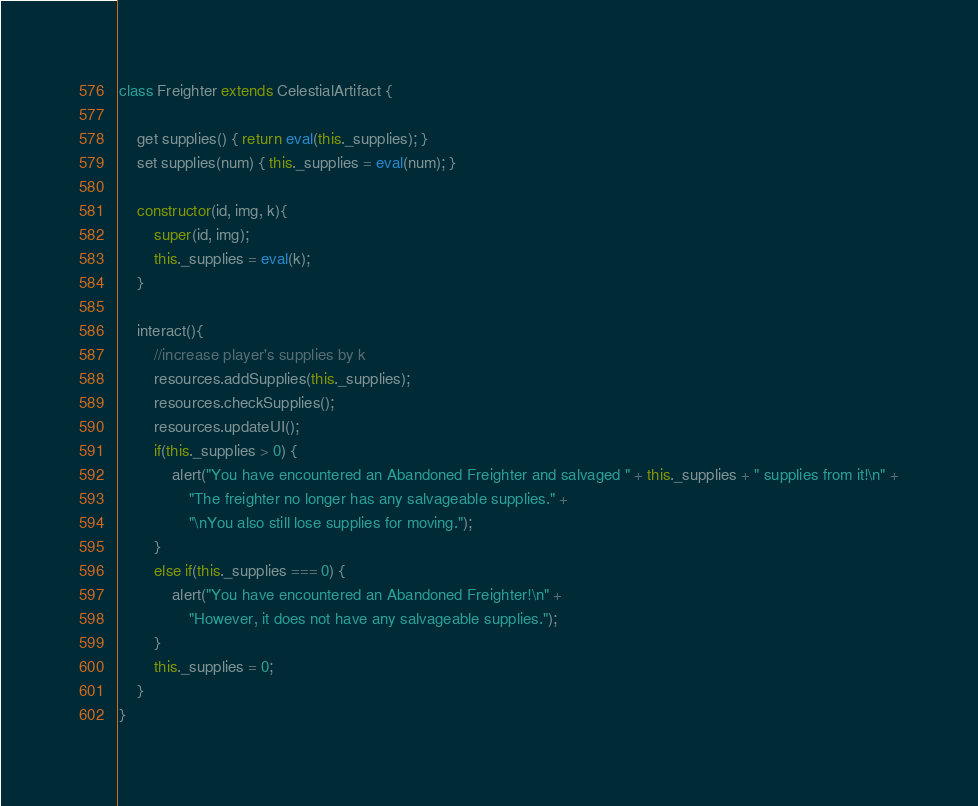<code> <loc_0><loc_0><loc_500><loc_500><_JavaScript_>class Freighter extends CelestialArtifact {

    get supplies() { return eval(this._supplies); }
    set supplies(num) { this._supplies = eval(num); }

    constructor(id, img, k){
        super(id, img);
        this._supplies = eval(k);
    }

    interact(){
        //increase player's supplies by k
        resources.addSupplies(this._supplies);
        resources.checkSupplies();
        resources.updateUI();
        if(this._supplies > 0) {
            alert("You have encountered an Abandoned Freighter and salvaged " + this._supplies + " supplies from it!\n" +
                "The freighter no longer has any salvageable supplies." +
                "\nYou also still lose supplies for moving.");
        }
        else if(this._supplies === 0) {
            alert("You have encountered an Abandoned Freighter!\n" +
                "However, it does not have any salvageable supplies.");
        }
        this._supplies = 0;
    }
}
</code> 